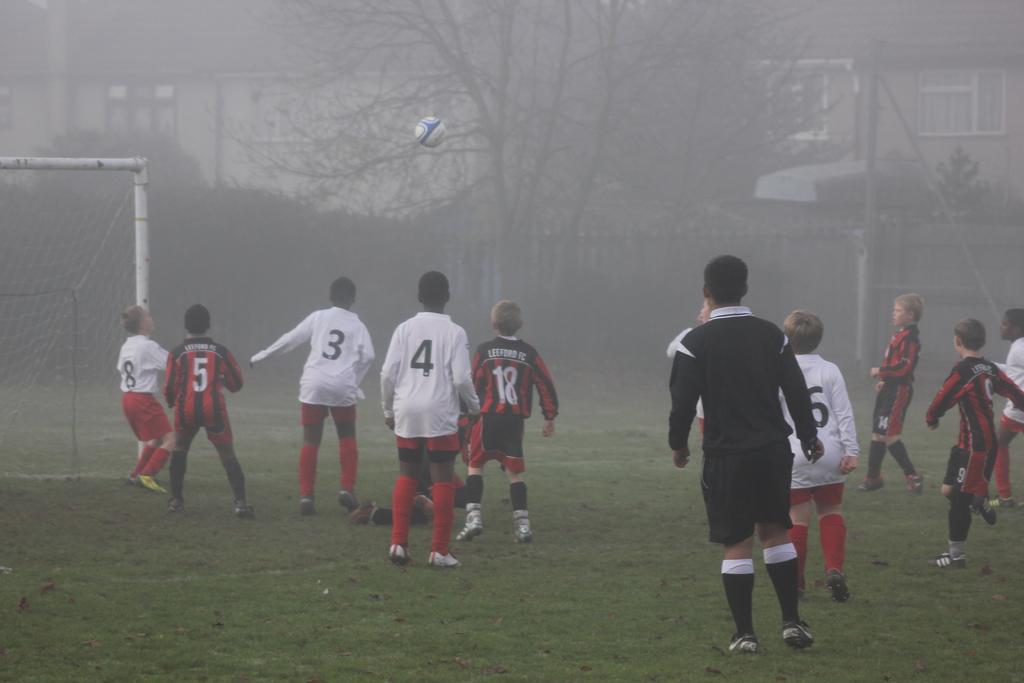What is the boy closest to the goals jersey number?
Offer a terse response. 8. Is there a player marked with 4?
Your answer should be compact. Yes. 